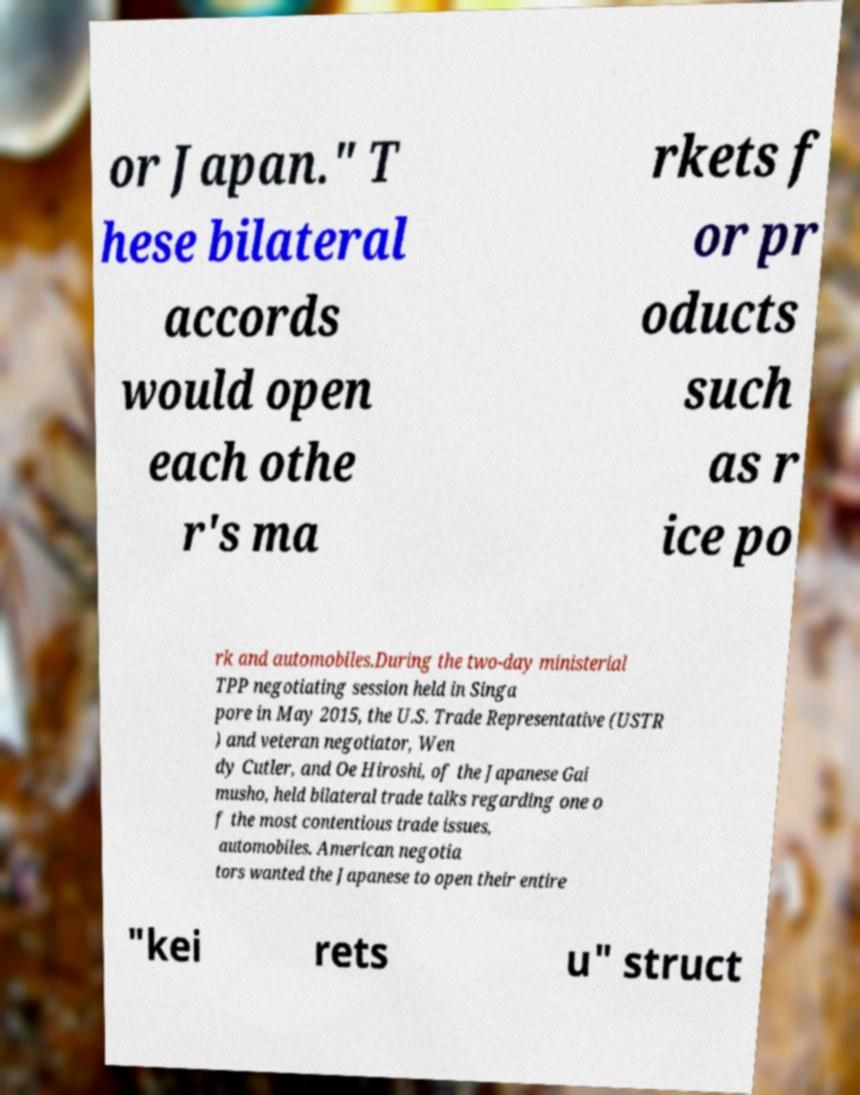Can you accurately transcribe the text from the provided image for me? or Japan." T hese bilateral accords would open each othe r's ma rkets f or pr oducts such as r ice po rk and automobiles.During the two-day ministerial TPP negotiating session held in Singa pore in May 2015, the U.S. Trade Representative (USTR ) and veteran negotiator, Wen dy Cutler, and Oe Hiroshi, of the Japanese Gai musho, held bilateral trade talks regarding one o f the most contentious trade issues, automobiles. American negotia tors wanted the Japanese to open their entire "kei rets u" struct 